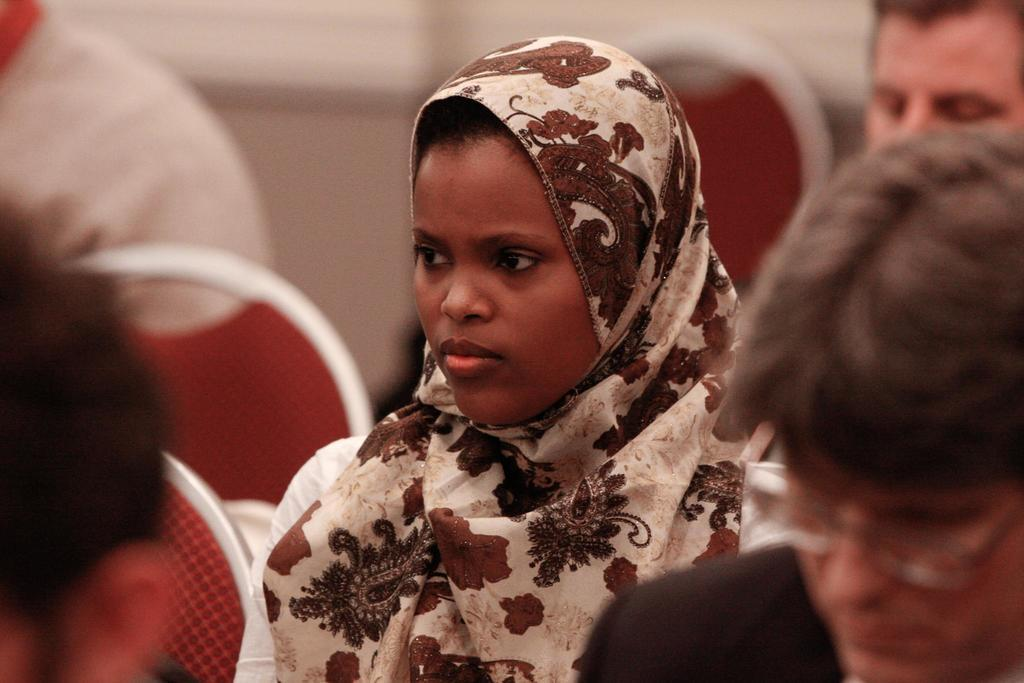What is in the foreground of the image? There are people in the foreground of the image. What are the people sitting on? The people are sitting on red chairs. Can you describe the background of the image? The background of the image is blurred. What type of metal is used to make the crib in the image? There is no crib present in the image. 